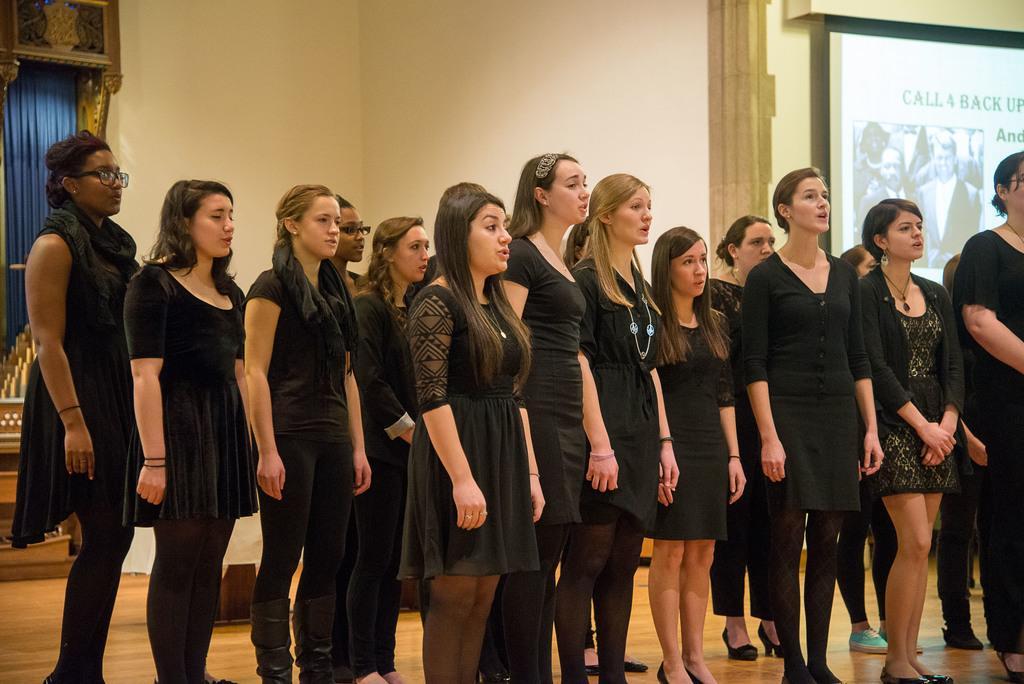Describe this image in one or two sentences. In this image I can see few women are wearing black color dresses, standing and looking at the right side. It seems like they are singing a song. In the background there is a wall. On the left side, I can see a blue color curtain. On the right side there is a screen is attached to the wall. 